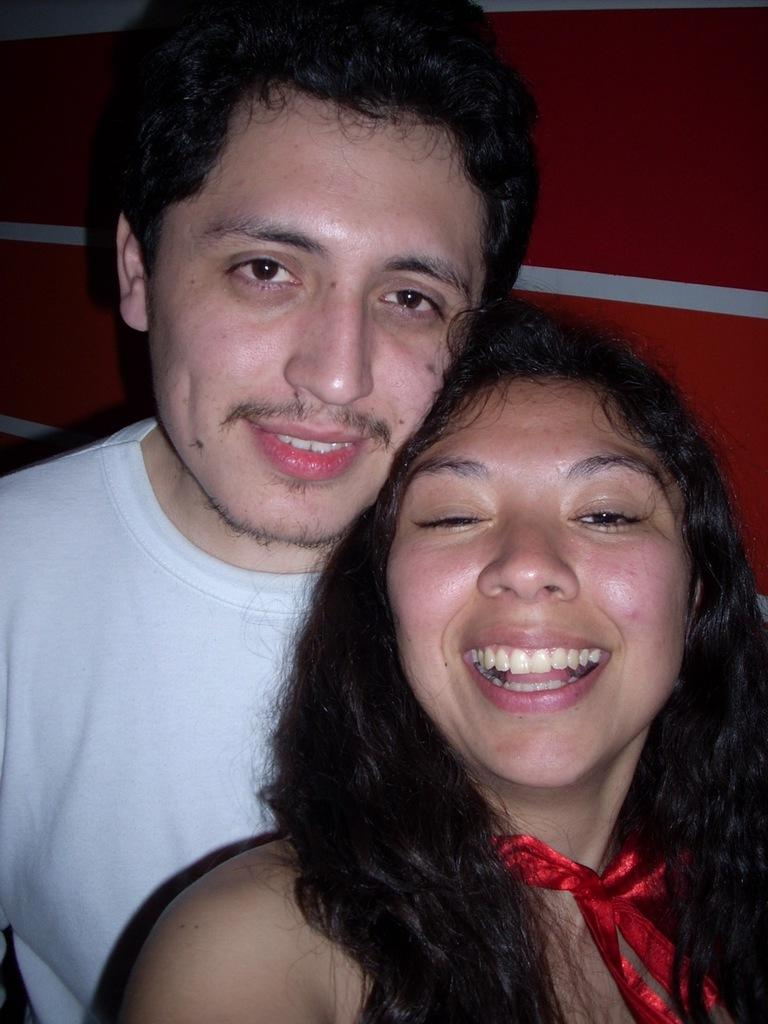How many people are present in the image? There are two people, a man and a woman, present in the image. What can be seen in the background of the image? There is a wall in the background of the image. What type of apple is the woman holding in the image? There is no apple present in the image; the woman is not holding anything. 